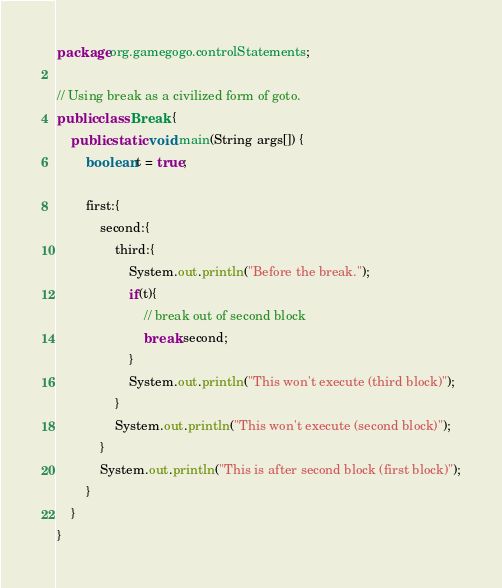<code> <loc_0><loc_0><loc_500><loc_500><_Java_>package org.gamegogo.controlStatements;

// Using break as a civilized form of goto.
public class Break {
    public static void main(String args[]) {
        boolean t = true;

        first:{
            second:{
                third:{
                    System.out.println("Before the break.");
                    if(t){
                        // break out of second block
                        break second;
                    }
                    System.out.println("This won't execute (third block)");
                }
                System.out.println("This won't execute (second block)");
            }
            System.out.println("This is after second block (first block)");
        }
    }
}
</code> 